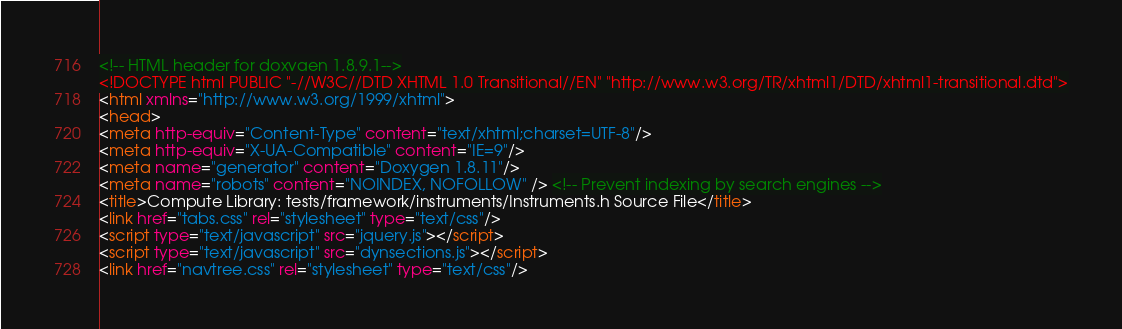Convert code to text. <code><loc_0><loc_0><loc_500><loc_500><_HTML_><!-- HTML header for doxygen 1.8.9.1-->
<!DOCTYPE html PUBLIC "-//W3C//DTD XHTML 1.0 Transitional//EN" "http://www.w3.org/TR/xhtml1/DTD/xhtml1-transitional.dtd">
<html xmlns="http://www.w3.org/1999/xhtml">
<head>
<meta http-equiv="Content-Type" content="text/xhtml;charset=UTF-8"/>
<meta http-equiv="X-UA-Compatible" content="IE=9"/>
<meta name="generator" content="Doxygen 1.8.11"/>
<meta name="robots" content="NOINDEX, NOFOLLOW" /> <!-- Prevent indexing by search engines -->
<title>Compute Library: tests/framework/instruments/Instruments.h Source File</title>
<link href="tabs.css" rel="stylesheet" type="text/css"/>
<script type="text/javascript" src="jquery.js"></script>
<script type="text/javascript" src="dynsections.js"></script>
<link href="navtree.css" rel="stylesheet" type="text/css"/></code> 